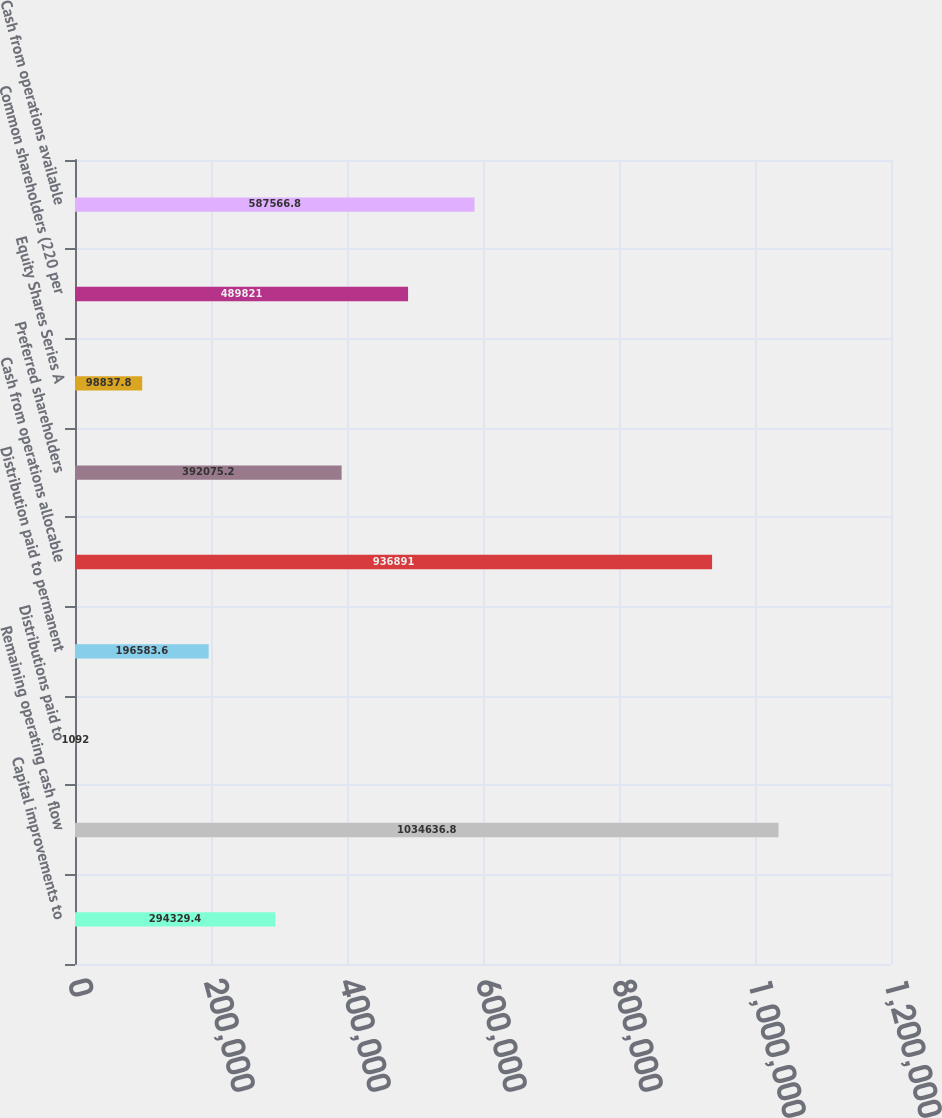Convert chart. <chart><loc_0><loc_0><loc_500><loc_500><bar_chart><fcel>Capital improvements to<fcel>Remaining operating cash flow<fcel>Distributions paid to<fcel>Distribution paid to permanent<fcel>Cash from operations allocable<fcel>Preferred shareholders<fcel>Equity Shares Series A<fcel>Common shareholders (220 per<fcel>Cash from operations available<nl><fcel>294329<fcel>1.03464e+06<fcel>1092<fcel>196584<fcel>936891<fcel>392075<fcel>98837.8<fcel>489821<fcel>587567<nl></chart> 